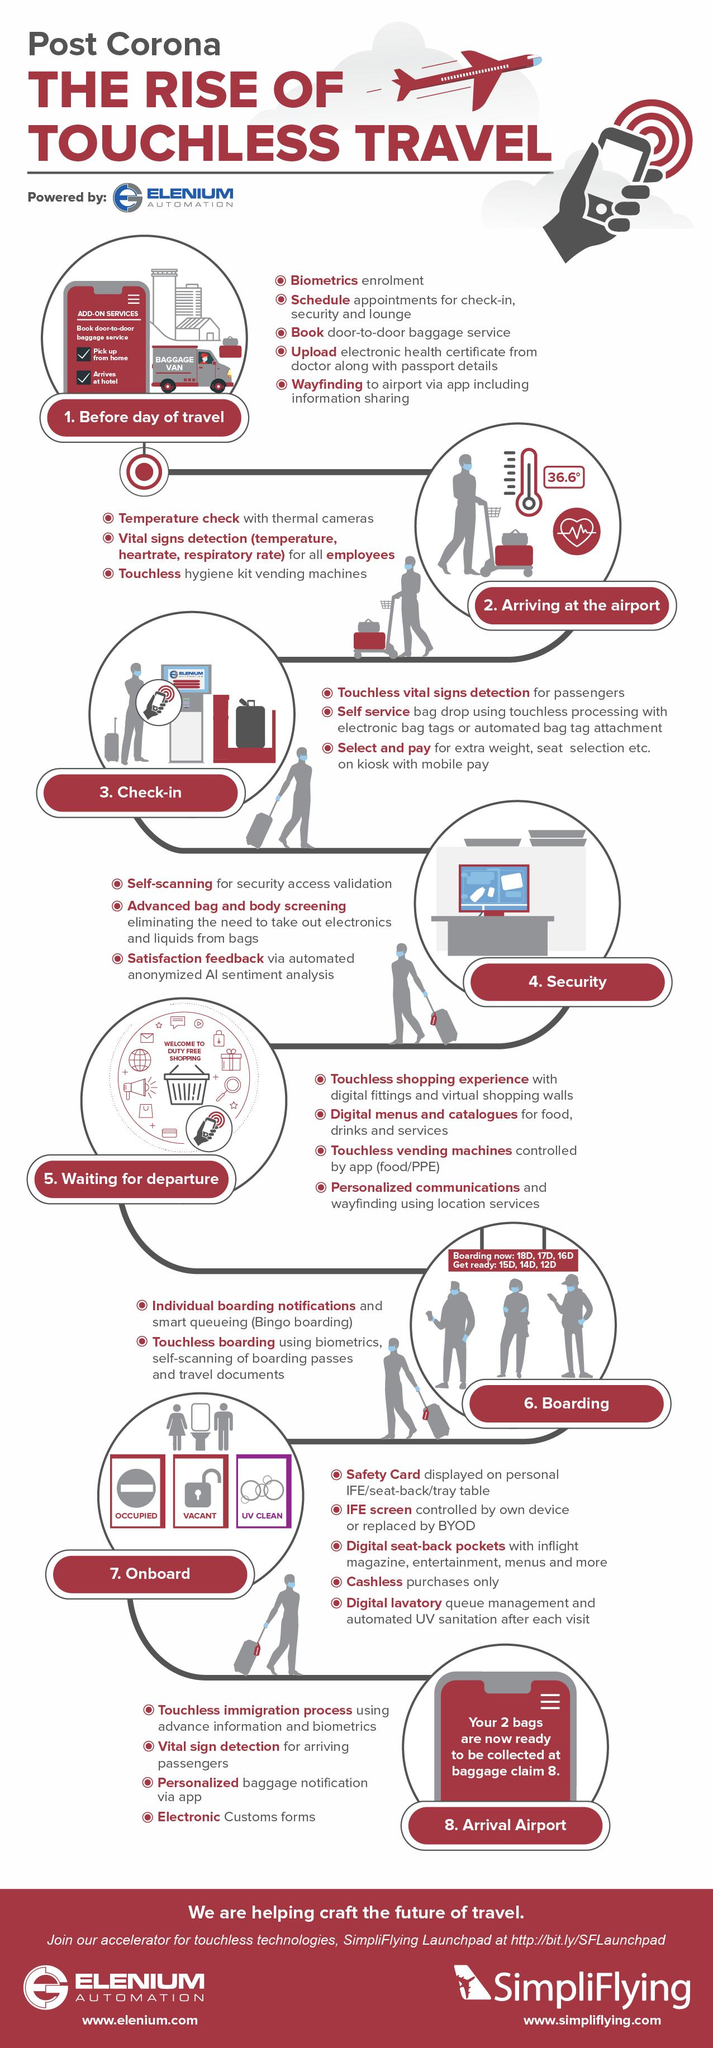Give some essential details in this illustration. During check-in, there are three procedures. After arriving at the airport, there are a total of 3 procedures. During security checking, a total of 3 procedures were conducted. 